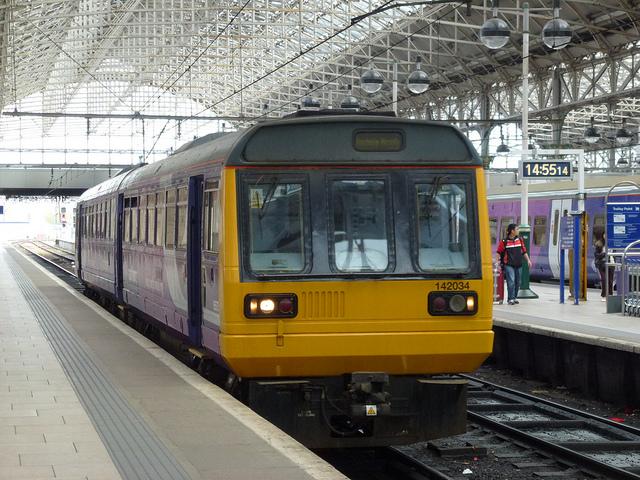What is crossing on top of the train station?
Answer briefly. Roof. What color is the train?
Give a very brief answer. Yellow. Is the train very long?
Give a very brief answer. No. Does this need to be cleaned?
Concise answer only. No. Are a lot of people waiting to get on?
Short answer required. No. What color are the lights on the train?
Answer briefly. White. 